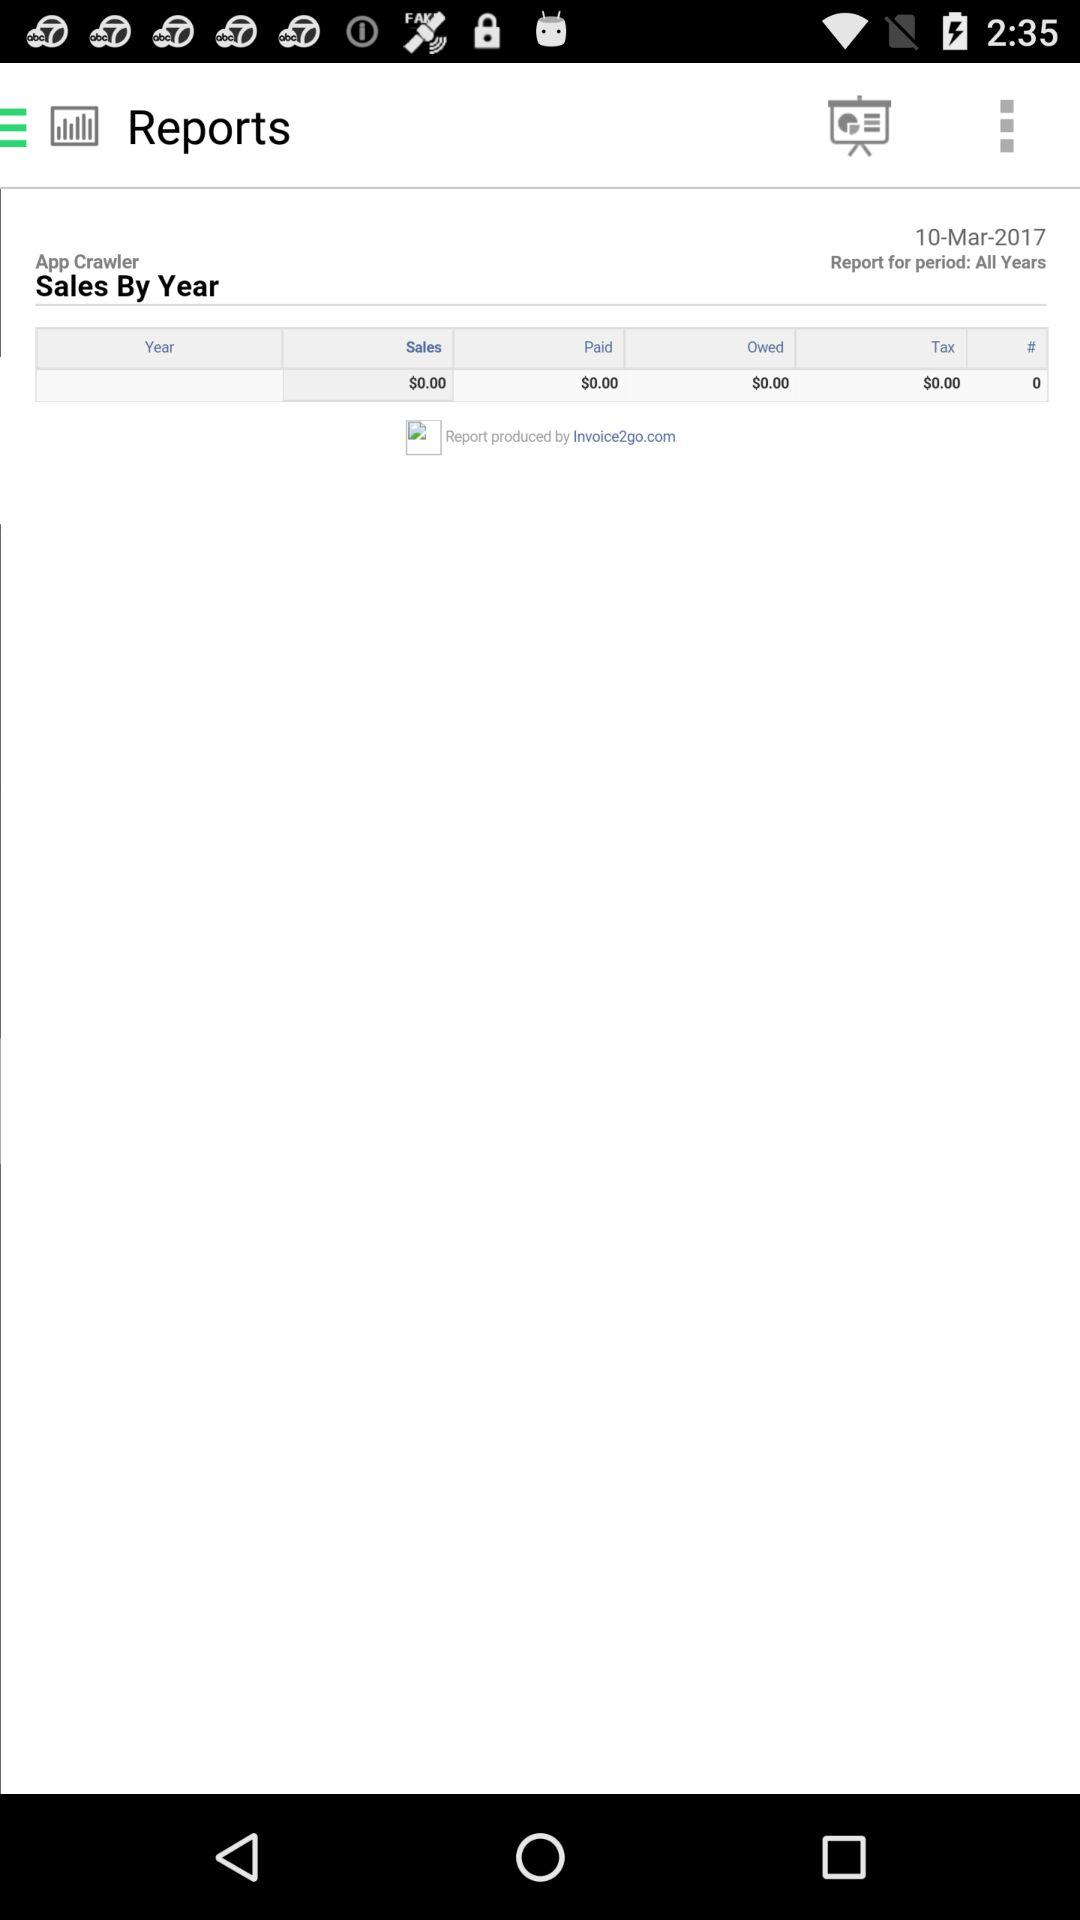For what date is the sales record shown? The sales record is shown for March 10, 2017. 